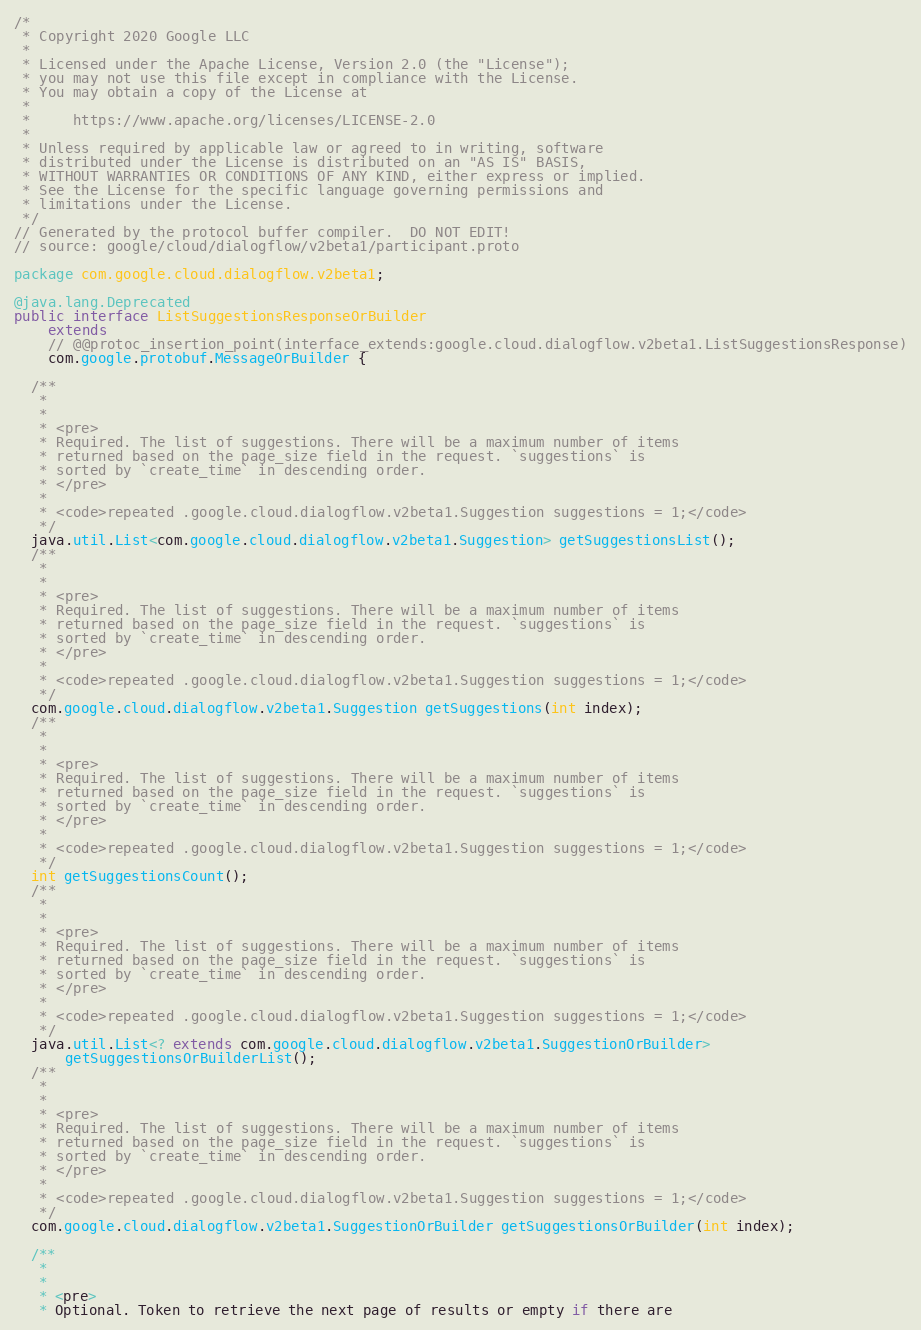<code> <loc_0><loc_0><loc_500><loc_500><_Java_>/*
 * Copyright 2020 Google LLC
 *
 * Licensed under the Apache License, Version 2.0 (the "License");
 * you may not use this file except in compliance with the License.
 * You may obtain a copy of the License at
 *
 *     https://www.apache.org/licenses/LICENSE-2.0
 *
 * Unless required by applicable law or agreed to in writing, software
 * distributed under the License is distributed on an "AS IS" BASIS,
 * WITHOUT WARRANTIES OR CONDITIONS OF ANY KIND, either express or implied.
 * See the License for the specific language governing permissions and
 * limitations under the License.
 */
// Generated by the protocol buffer compiler.  DO NOT EDIT!
// source: google/cloud/dialogflow/v2beta1/participant.proto

package com.google.cloud.dialogflow.v2beta1;

@java.lang.Deprecated
public interface ListSuggestionsResponseOrBuilder
    extends
    // @@protoc_insertion_point(interface_extends:google.cloud.dialogflow.v2beta1.ListSuggestionsResponse)
    com.google.protobuf.MessageOrBuilder {

  /**
   *
   *
   * <pre>
   * Required. The list of suggestions. There will be a maximum number of items
   * returned based on the page_size field in the request. `suggestions` is
   * sorted by `create_time` in descending order.
   * </pre>
   *
   * <code>repeated .google.cloud.dialogflow.v2beta1.Suggestion suggestions = 1;</code>
   */
  java.util.List<com.google.cloud.dialogflow.v2beta1.Suggestion> getSuggestionsList();
  /**
   *
   *
   * <pre>
   * Required. The list of suggestions. There will be a maximum number of items
   * returned based on the page_size field in the request. `suggestions` is
   * sorted by `create_time` in descending order.
   * </pre>
   *
   * <code>repeated .google.cloud.dialogflow.v2beta1.Suggestion suggestions = 1;</code>
   */
  com.google.cloud.dialogflow.v2beta1.Suggestion getSuggestions(int index);
  /**
   *
   *
   * <pre>
   * Required. The list of suggestions. There will be a maximum number of items
   * returned based on the page_size field in the request. `suggestions` is
   * sorted by `create_time` in descending order.
   * </pre>
   *
   * <code>repeated .google.cloud.dialogflow.v2beta1.Suggestion suggestions = 1;</code>
   */
  int getSuggestionsCount();
  /**
   *
   *
   * <pre>
   * Required. The list of suggestions. There will be a maximum number of items
   * returned based on the page_size field in the request. `suggestions` is
   * sorted by `create_time` in descending order.
   * </pre>
   *
   * <code>repeated .google.cloud.dialogflow.v2beta1.Suggestion suggestions = 1;</code>
   */
  java.util.List<? extends com.google.cloud.dialogflow.v2beta1.SuggestionOrBuilder>
      getSuggestionsOrBuilderList();
  /**
   *
   *
   * <pre>
   * Required. The list of suggestions. There will be a maximum number of items
   * returned based on the page_size field in the request. `suggestions` is
   * sorted by `create_time` in descending order.
   * </pre>
   *
   * <code>repeated .google.cloud.dialogflow.v2beta1.Suggestion suggestions = 1;</code>
   */
  com.google.cloud.dialogflow.v2beta1.SuggestionOrBuilder getSuggestionsOrBuilder(int index);

  /**
   *
   *
   * <pre>
   * Optional. Token to retrieve the next page of results or empty if there are</code> 